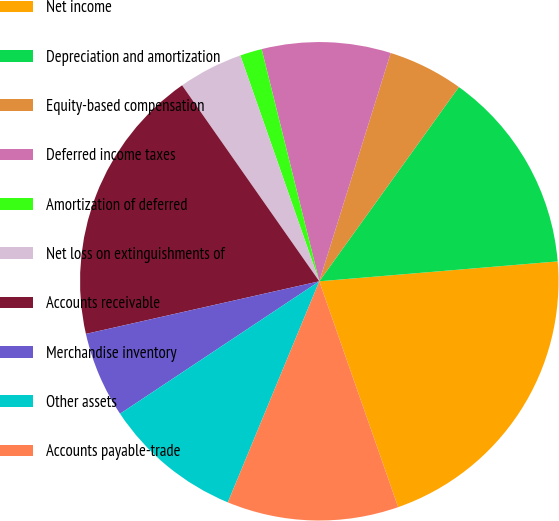Convert chart. <chart><loc_0><loc_0><loc_500><loc_500><pie_chart><fcel>Net income<fcel>Depreciation and amortization<fcel>Equity-based compensation<fcel>Deferred income taxes<fcel>Amortization of deferred<fcel>Net loss on extinguishments of<fcel>Accounts receivable<fcel>Merchandise inventory<fcel>Other assets<fcel>Accounts payable-trade<nl><fcel>20.98%<fcel>13.76%<fcel>5.09%<fcel>8.7%<fcel>1.48%<fcel>4.37%<fcel>18.81%<fcel>5.81%<fcel>9.42%<fcel>11.59%<nl></chart> 